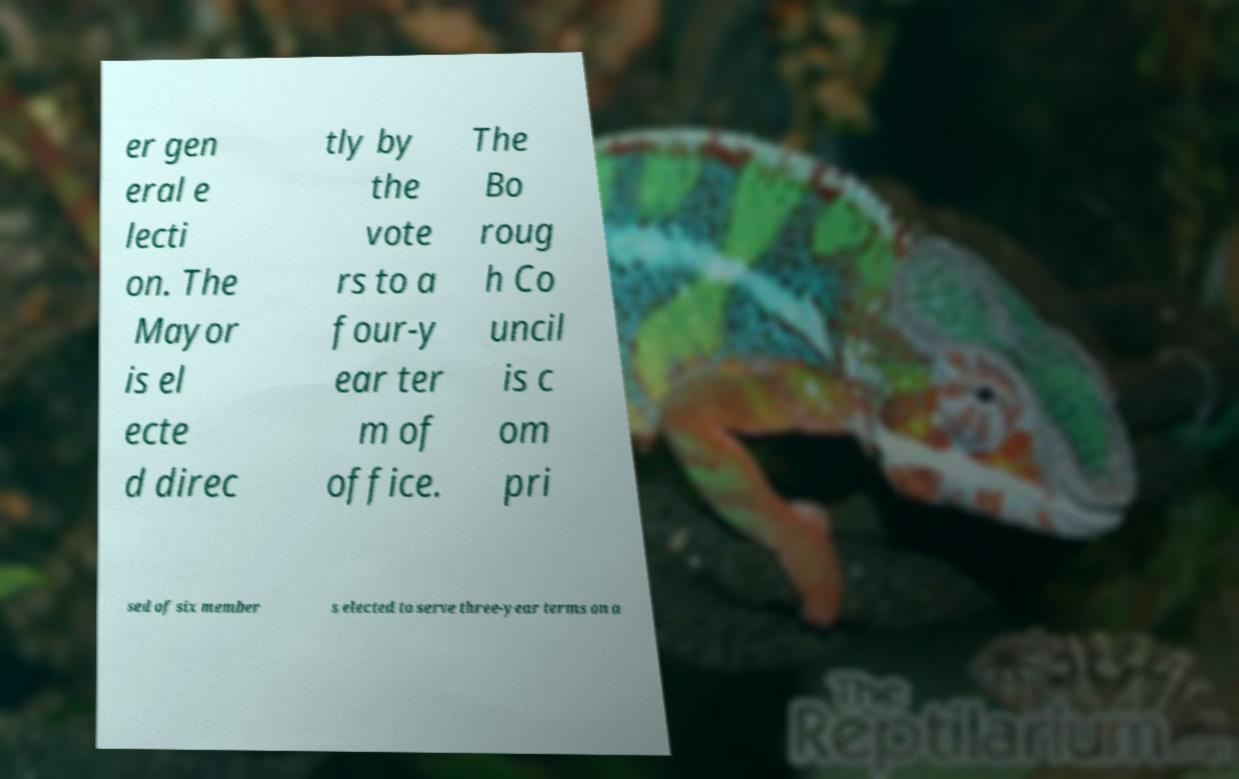For documentation purposes, I need the text within this image transcribed. Could you provide that? er gen eral e lecti on. The Mayor is el ecte d direc tly by the vote rs to a four-y ear ter m of office. The Bo roug h Co uncil is c om pri sed of six member s elected to serve three-year terms on a 